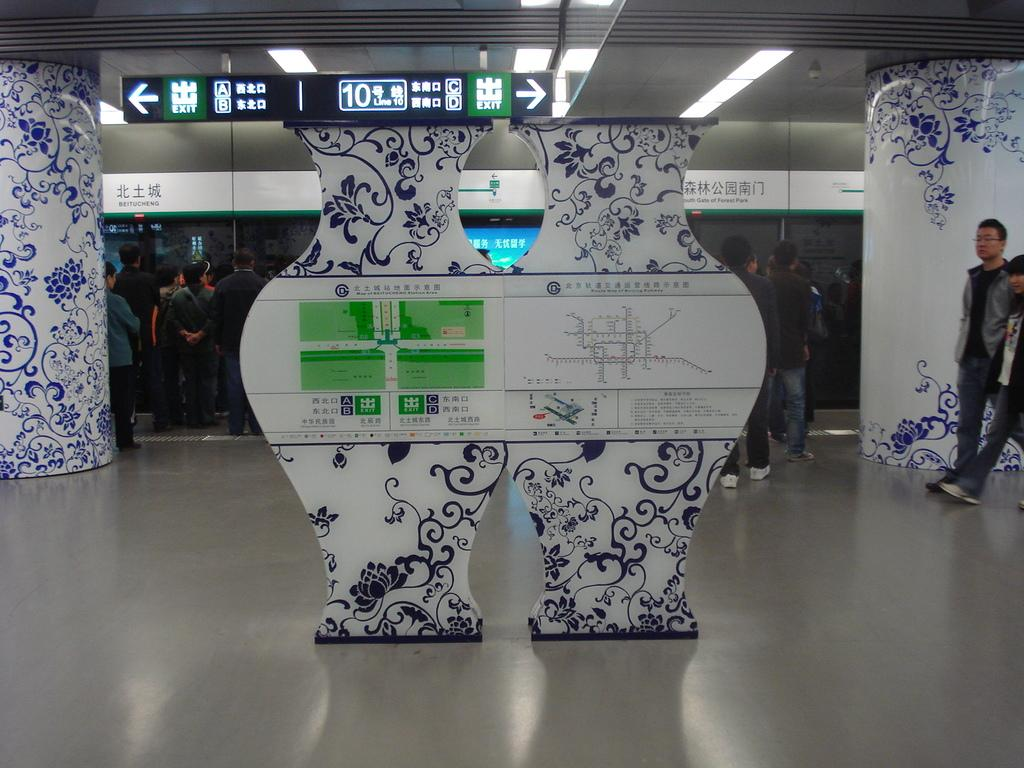What can be seen on the boards in the image? There are boards with route maps in the image. What are the two people on the right side of the image doing? The two people on the right side of the image are walking. What is happening in the background of the image? There are people standing in the background. Can you tell me how many friends the kitten has in the image? There is no kitten present in the image, so it is not possible to determine how many friends it might have. What is the kitten writing on the boards with route maps? There is no kitten present in the image, and therefore no such activity can be observed. 